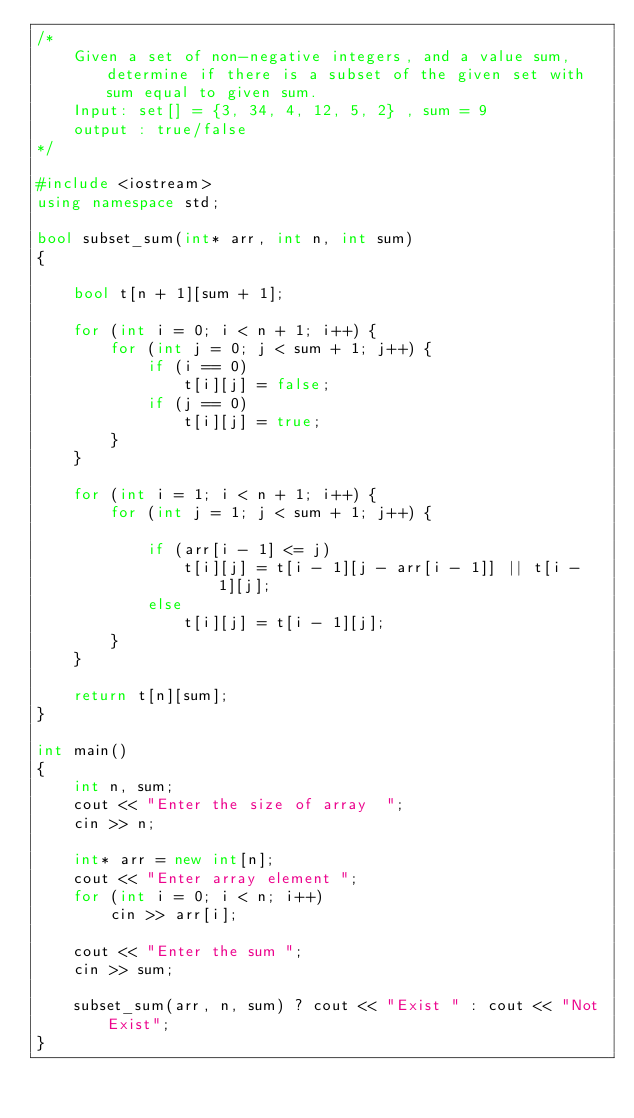Convert code to text. <code><loc_0><loc_0><loc_500><loc_500><_C++_>/*
    Given a set of non-negative integers, and a value sum, determine if there is a subset of the given set with sum equal to given sum.
    Input: set[] = {3, 34, 4, 12, 5, 2} , sum = 9
    output : true/false
*/

#include <iostream>
using namespace std;

bool subset_sum(int* arr, int n, int sum)
{

    bool t[n + 1][sum + 1];

    for (int i = 0; i < n + 1; i++) {
        for (int j = 0; j < sum + 1; j++) {
            if (i == 0)
                t[i][j] = false;
            if (j == 0)
                t[i][j] = true;
        }
    }

    for (int i = 1; i < n + 1; i++) {
        for (int j = 1; j < sum + 1; j++) {

            if (arr[i - 1] <= j)
                t[i][j] = t[i - 1][j - arr[i - 1]] || t[i - 1][j];
            else
                t[i][j] = t[i - 1][j];
        }
    }

    return t[n][sum];
}

int main()
{
    int n, sum;
    cout << "Enter the size of array  ";
    cin >> n;

    int* arr = new int[n];
    cout << "Enter array element ";
    for (int i = 0; i < n; i++)
        cin >> arr[i];

    cout << "Enter the sum ";
    cin >> sum;

    subset_sum(arr, n, sum) ? cout << "Exist " : cout << "Not Exist";
}
</code> 